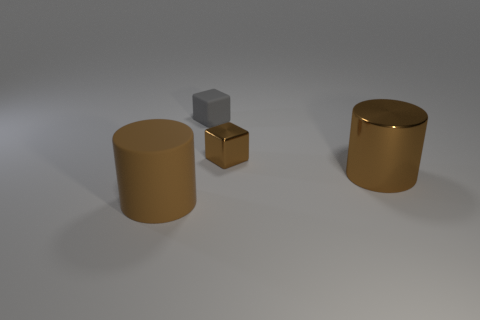What shape is the tiny object that is in front of the gray rubber thing behind the big rubber cylinder?
Give a very brief answer. Cube. How many things are brown things that are in front of the tiny brown cube or brown objects to the left of the large metal object?
Offer a terse response. 3. There is a brown object that is the same material as the tiny gray thing; what is its shape?
Provide a succinct answer. Cylinder. Are there any other things that are the same color as the metal block?
Your answer should be compact. Yes. There is another large brown thing that is the same shape as the big rubber object; what material is it?
Offer a terse response. Metal. What number of other things are there of the same size as the gray matte block?
Your answer should be very brief. 1. What is the gray thing made of?
Your answer should be very brief. Rubber. Are there more matte cylinders behind the small shiny block than large shiny objects?
Offer a very short reply. No. Are any tiny blue rubber cylinders visible?
Offer a very short reply. No. How many other objects are the same shape as the big rubber object?
Provide a succinct answer. 1. 